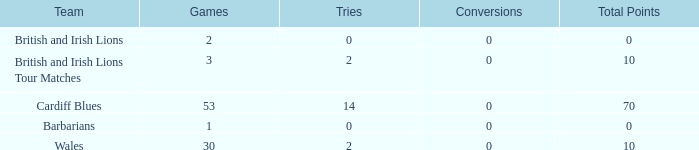What is the average number of conversions for the Cardiff Blues with less than 14 tries? None. 